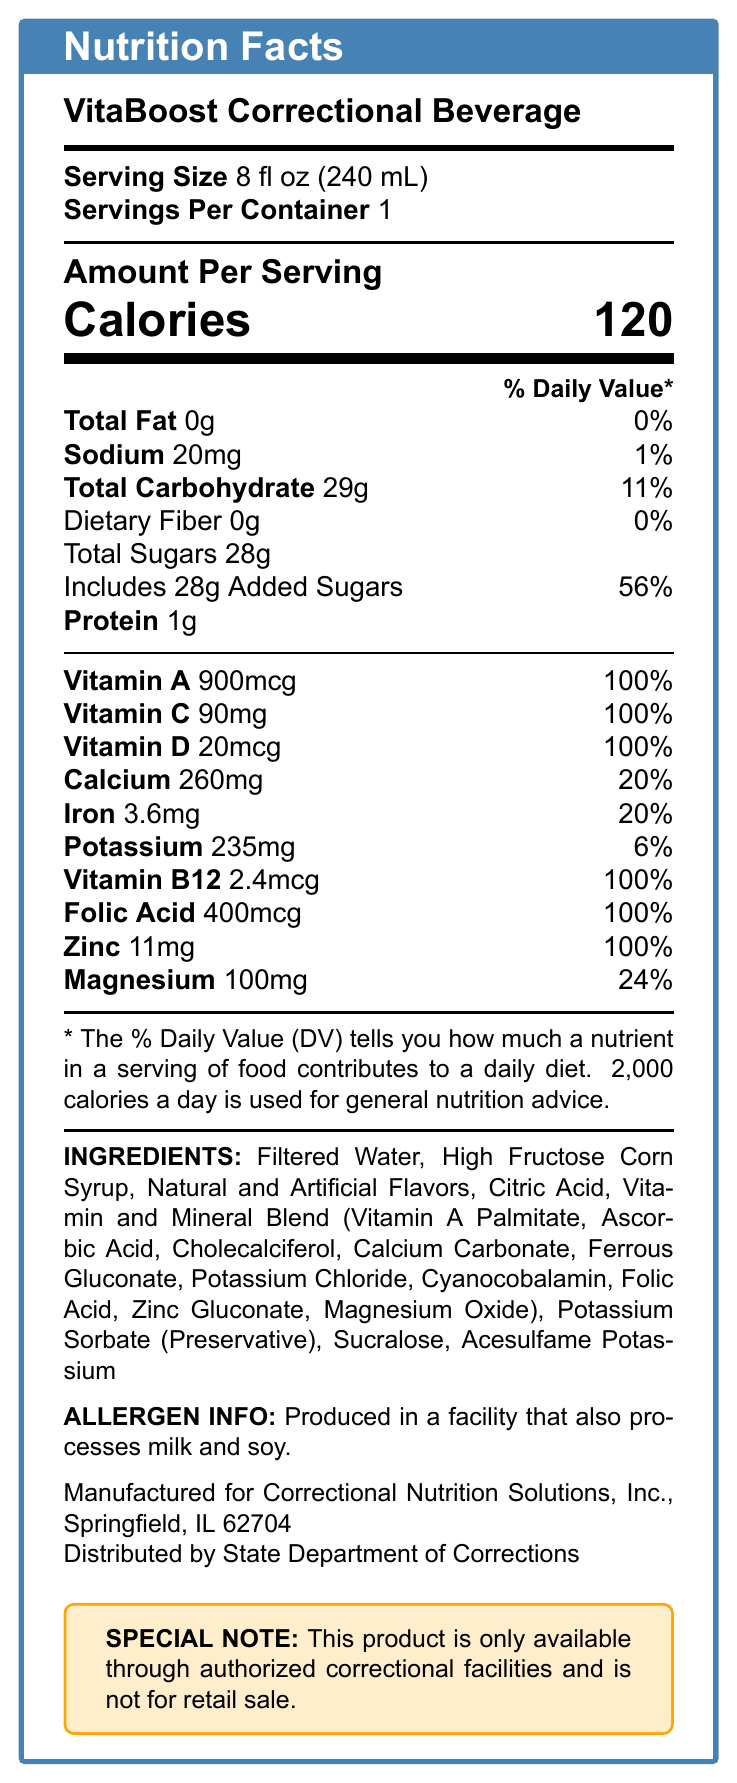what is the serving size of the VitaBoost Correctional Beverage? The information is directly mentioned in the document under "Serving Size".
Answer: 8 fl oz (240 mL) how many calories are there per serving? The document mentions the calorie content directly under "Amount Per Serving".
Answer: 120 what is the percentage of daily value of added sugars per serving? The document lists "Includes 28g Added Sugars" with a percentage of daily value of "56%" next to it.
Answer: 56% which vitamins are included at 100% of the daily value? This information is detailed in the section listing vitamins and their percentages.
Answer: Vitamin A, Vitamin C, Vitamin D, Vitamin B12, Folic Acid, Zinc how much sodium does the VitaBoost Correctional Beverage contain? The sodium content is given clearly in the document as "Sodium 20mg".
Answer: 20mg what are the primary ingredients in the VitaBoost Correctional Beverage? This is taken from the "INGREDIENTS" section of the document.
Answer: Filtered Water, High Fructose Corn Syrup, Natural and Artificial Flavors, Citric Acid, Vitamin and Mineral Blend, Potassium Sorbate, Sucralose, Acesulfame Potassium is there any protein in the beverage? The document specifies "Protein 1g" under "Amount Per Serving".
Answer: Yes which of the following minerals are included in the VitaBoost beverage? A. Calcium B. Iron C. Selenium D. Magnesium The document includes the amounts and daily values for Calcium, Iron, and Magnesium but does not mention Selenium.
Answer: A, B, and D what percentage of daily value is provided by calcium per serving? A. 15% B. 20% C. 25% D. 30% The document lists Calcium with an amount of "260mg" and a percent daily value of "20%".
Answer: B does the beverage contain any allergens? The document has the following note under "ALLERGEN INFO": "Produced in a facility that also processes milk and soy."
Answer: Yes can the VitaBoost Correctional Beverage be bought in retail stores? The document specifies that the product "is only available through authorized correctional facilities and is not for retail sale."
Answer: No describe the main purpose of the VitaBoost Correctional Beverage. This summary is directly mentioned in the "productDescription" section of the document.
Answer: VitaBoost is a fortified beverage designed to supplement the nutritional needs of incarcerated individuals. It provides essential vitamins and minerals that may be lacking in standard prison diets. is the sodium content in the VitaBoost Correctional Beverage high compared to other nutrients? The sodium content is 20mg which is 1% of the daily value, relatively low compared to other nutrients like added sugars at 56%.
Answer: No what is the total carbohydrate content in the VitaBoost beverage? The document specifies "Total Carbohydrate 29g" under "Amount Per Serving".
Answer: 29g what type of preservative is included in the ingredients? This is listed among the ingredients in the document.
Answer: Potassium Sorbate how much iron is there per serving? The document lists Iron with an amount of 3.6mg.
Answer: 3.6mg does the document specify how frequently inmates should consume the VitaBoost beverage? The document does not provide information on the frequency of consumption for inmates.
Answer: Not enough information 